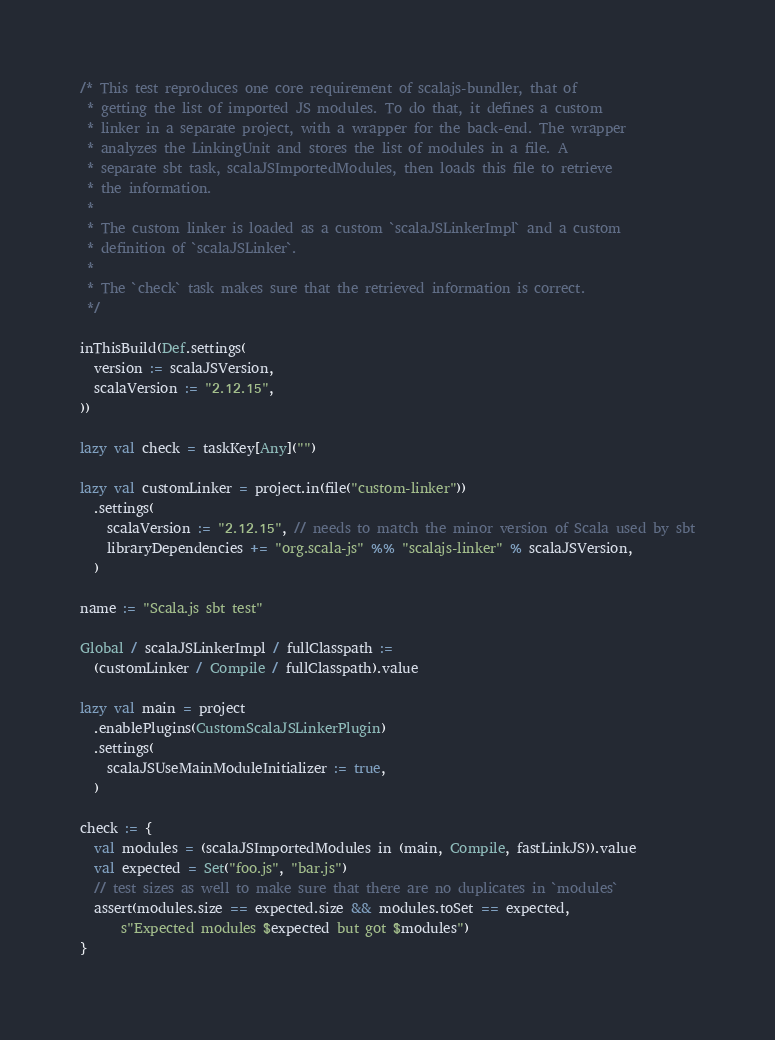<code> <loc_0><loc_0><loc_500><loc_500><_Scala_>/* This test reproduces one core requirement of scalajs-bundler, that of
 * getting the list of imported JS modules. To do that, it defines a custom
 * linker in a separate project, with a wrapper for the back-end. The wrapper
 * analyzes the LinkingUnit and stores the list of modules in a file. A
 * separate sbt task, scalaJSImportedModules, then loads this file to retrieve
 * the information.
 *
 * The custom linker is loaded as a custom `scalaJSLinkerImpl` and a custom
 * definition of `scalaJSLinker`.
 *
 * The `check` task makes sure that the retrieved information is correct.
 */

inThisBuild(Def.settings(
  version := scalaJSVersion,
  scalaVersion := "2.12.15",
))

lazy val check = taskKey[Any]("")

lazy val customLinker = project.in(file("custom-linker"))
  .settings(
    scalaVersion := "2.12.15", // needs to match the minor version of Scala used by sbt
    libraryDependencies += "org.scala-js" %% "scalajs-linker" % scalaJSVersion,
  )

name := "Scala.js sbt test"

Global / scalaJSLinkerImpl / fullClasspath :=
  (customLinker / Compile / fullClasspath).value

lazy val main = project
  .enablePlugins(CustomScalaJSLinkerPlugin)
  .settings(
    scalaJSUseMainModuleInitializer := true,
  )

check := {
  val modules = (scalaJSImportedModules in (main, Compile, fastLinkJS)).value
  val expected = Set("foo.js", "bar.js")
  // test sizes as well to make sure that there are no duplicates in `modules`
  assert(modules.size == expected.size && modules.toSet == expected,
      s"Expected modules $expected but got $modules")
}
</code> 